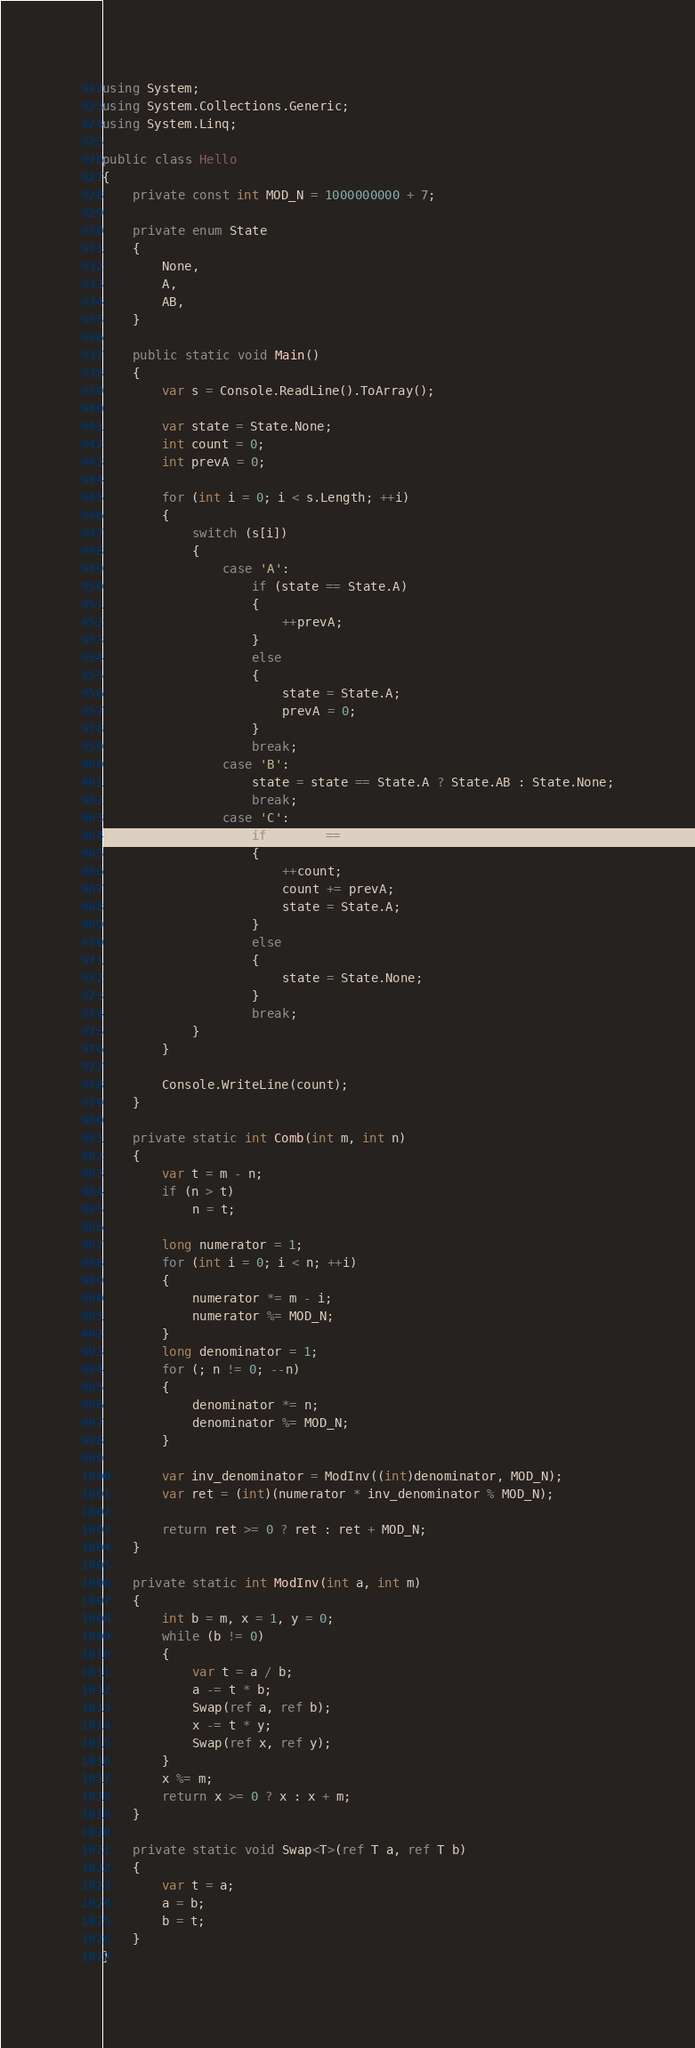<code> <loc_0><loc_0><loc_500><loc_500><_C#_>using System;
using System.Collections.Generic;
using System.Linq;

public class Hello
{
    private const int MOD_N = 1000000000 + 7;

    private enum State
    {
        None,
        A,
        AB,
    }

    public static void Main()
    {
        var s = Console.ReadLine().ToArray();

        var state = State.None;
        int count = 0;
        int prevA = 0;

        for (int i = 0; i < s.Length; ++i)
        {
            switch (s[i])
            {
                case 'A':
                    if (state == State.A)
                    {
                        ++prevA;
                    }
                    else
                    {
                        state = State.A;
                        prevA = 0;
                    }
                    break;
                case 'B':
                    state = state == State.A ? State.AB : State.None;
                    break;
                case 'C':
                    if (state == State.AB)
                    {
                        ++count;
                        count += prevA;
                        state = State.A;
                    }
                    else
                    {
                        state = State.None;
                    }
                    break;
            }
        }

        Console.WriteLine(count);
    }

    private static int Comb(int m, int n)
    {
        var t = m - n;
        if (n > t)
            n = t;

        long numerator = 1;
        for (int i = 0; i < n; ++i)
        {
            numerator *= m - i;
            numerator %= MOD_N;
        }
        long denominator = 1;
        for (; n != 0; --n)
        {
            denominator *= n;
            denominator %= MOD_N;
        }

        var inv_denominator = ModInv((int)denominator, MOD_N);
        var ret = (int)(numerator * inv_denominator % MOD_N);

        return ret >= 0 ? ret : ret + MOD_N;
    }

    private static int ModInv(int a, int m)
    {
        int b = m, x = 1, y = 0;
        while (b != 0)
        {
            var t = a / b;
            a -= t * b;
            Swap(ref a, ref b);
            x -= t * y;
            Swap(ref x, ref y);
        }
        x %= m;
        return x >= 0 ? x : x + m;
    }

    private static void Swap<T>(ref T a, ref T b)
    {
        var t = a;
        a = b;
        b = t;
    }
}
</code> 